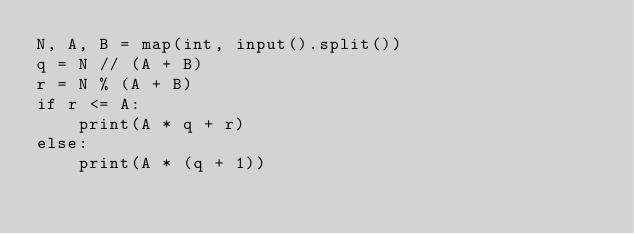Convert code to text. <code><loc_0><loc_0><loc_500><loc_500><_Python_>N, A, B = map(int, input().split())
q = N // (A + B)
r = N % (A + B)
if r <= A:
    print(A * q + r)
else:
    print(A * (q + 1))</code> 